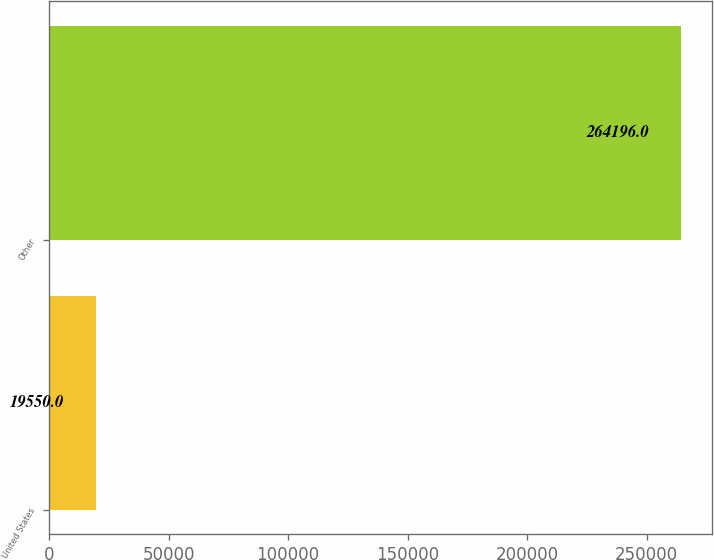<chart> <loc_0><loc_0><loc_500><loc_500><bar_chart><fcel>United States<fcel>Other<nl><fcel>19550<fcel>264196<nl></chart> 